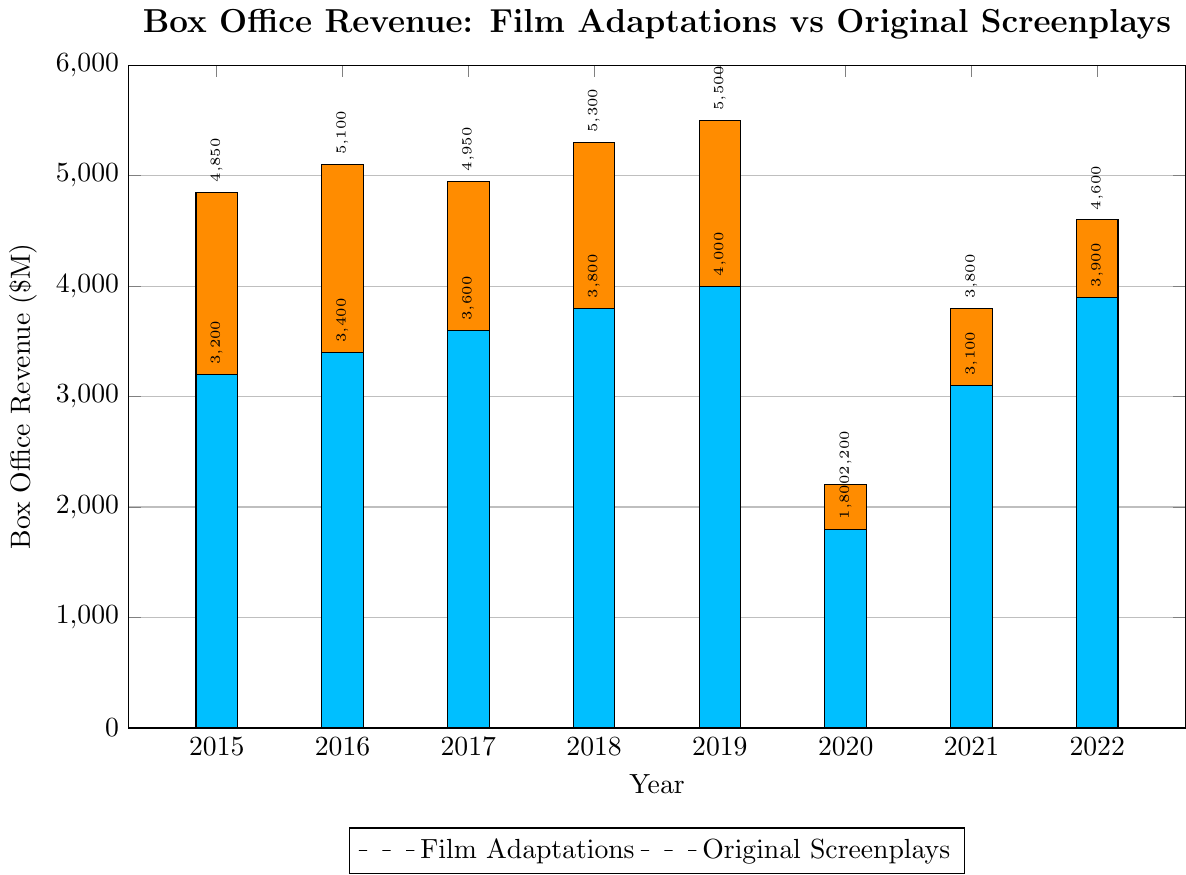Which year had the highest box office revenue for film adaptations? The height of the bar representing the year 2019 for film adaptations is the highest among all years.
Answer: 2019 By how much did the box office revenue for original screenplays increase from 2020 to 2021? The bar for original screenplays in 2020 shows 1800, and in 2021 it shows 3100. The increase is 3100 - 1800.
Answer: 1300 Compare the box office revenue between film adaptations and original screenplays in 2022. Which one was higher and by how much? The bar for film adaptations in 2022 shows 4600, and for original screenplays, it shows 3900. The difference is 4600 - 3900.
Answer: Film adaptations by 700 What is the average box office revenue for original screenplays over the years 2015 to 2017? The values for the years 2015 to 2017 for original screenplays are 3200, 3400, and 3600. The sum is 3200 + 3400 + 3600 = 10200. The average is 10200 / 3.
Answer: 3400 Between which two consecutive years did film adaptations see the greatest decrease in box office revenue? The largest decrease between two consecutive years for film adaptations is from 2019 (5500) to 2020 (2200), a drop of 5500 - 2200 = 3300.
Answer: 2019 to 2020 Based on visual differences, did film adaptations or original screenplays suffer a larger decline in revenue from 2019 to 2020? The decline for film adaptations from 2019 to 2020 is from 5500 to 2200, and for original screenplays, it's from 4000 to 1800. Visual height comparison shows a decline of 3300 for adaptations and 2200 for original screenplays.
Answer: Film adaptations What was the total combined revenue of film adaptations and original screenplays in 2019? The revenue for film adaptations in 2019 is 5500, and for original screenplays, it is 4000. The combined total is 5500 + 4000.
Answer: 9500 Which year showed the smallest difference in box office revenue between film adaptations and original screenplays? The differences are: 
2015: 4850 - 3200 = 1650 
2016: 5100 - 3400 = 1700 
2017: 4950 - 3600 = 1350 
2018: 5300 - 3800 = 1500 
2019: 5500 - 4000 = 1500 
2020: 2200 - 1800 = 400 
2021: 3800 - 3100 = 700 
2022: 4600 - 3900 = 700 
The smallest difference is in 2020.
Answer: 2020 In which year did original screenplays get closest to the revenue of film adaptations? The smallest difference between the revenue of film adaptations and original screenplays occurs in 2020, with a difference of $400M.
Answer: 2020 